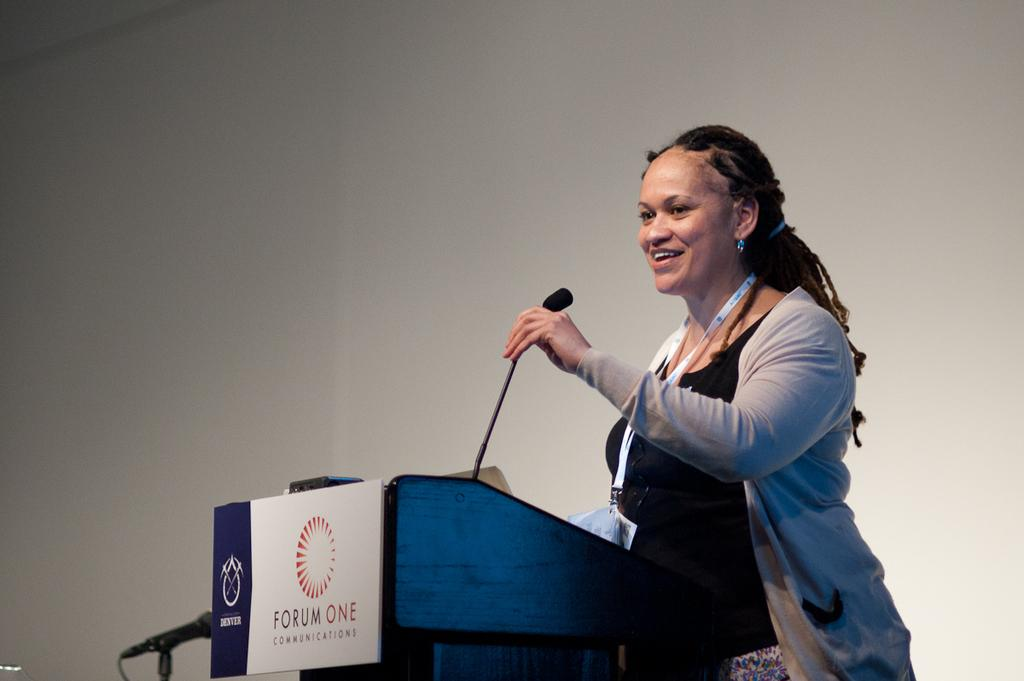Who is the main subject in the image? There is a woman in the image. What is the woman doing in the image? The woman is standing near a speech desk. What object is the woman holding in her hand? The woman is holding a microphone in her hand. How many trees can be seen in the image? There are no trees visible in the image. 